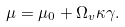<formula> <loc_0><loc_0><loc_500><loc_500>\mu = \mu _ { 0 } + \Omega _ { v } \kappa \gamma .</formula> 